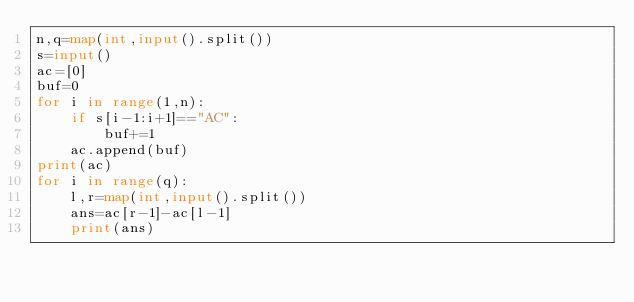<code> <loc_0><loc_0><loc_500><loc_500><_Python_>n,q=map(int,input().split())
s=input()
ac=[0]
buf=0
for i in range(1,n):
    if s[i-1:i+1]=="AC":
        buf+=1
    ac.append(buf)
print(ac)
for i in range(q):
    l,r=map(int,input().split())
    ans=ac[r-1]-ac[l-1]
    print(ans)</code> 